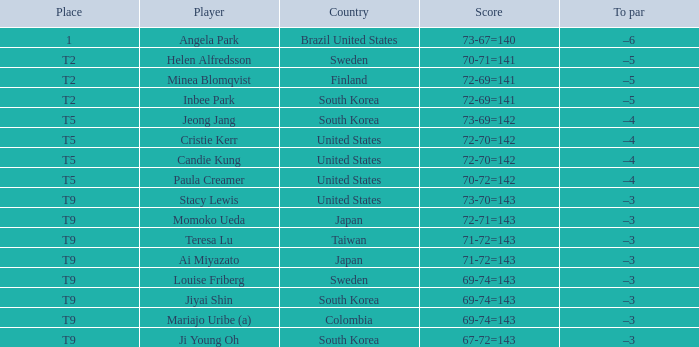What score did taiwan achieve? 71-72=143. Write the full table. {'header': ['Place', 'Player', 'Country', 'Score', 'To par'], 'rows': [['1', 'Angela Park', 'Brazil United States', '73-67=140', '–6'], ['T2', 'Helen Alfredsson', 'Sweden', '70-71=141', '–5'], ['T2', 'Minea Blomqvist', 'Finland', '72-69=141', '–5'], ['T2', 'Inbee Park', 'South Korea', '72-69=141', '–5'], ['T5', 'Jeong Jang', 'South Korea', '73-69=142', '–4'], ['T5', 'Cristie Kerr', 'United States', '72-70=142', '–4'], ['T5', 'Candie Kung', 'United States', '72-70=142', '–4'], ['T5', 'Paula Creamer', 'United States', '70-72=142', '–4'], ['T9', 'Stacy Lewis', 'United States', '73-70=143', '–3'], ['T9', 'Momoko Ueda', 'Japan', '72-71=143', '–3'], ['T9', 'Teresa Lu', 'Taiwan', '71-72=143', '–3'], ['T9', 'Ai Miyazato', 'Japan', '71-72=143', '–3'], ['T9', 'Louise Friberg', 'Sweden', '69-74=143', '–3'], ['T9', 'Jiyai Shin', 'South Korea', '69-74=143', '–3'], ['T9', 'Mariajo Uribe (a)', 'Colombia', '69-74=143', '–3'], ['T9', 'Ji Young Oh', 'South Korea', '67-72=143', '–3']]} 